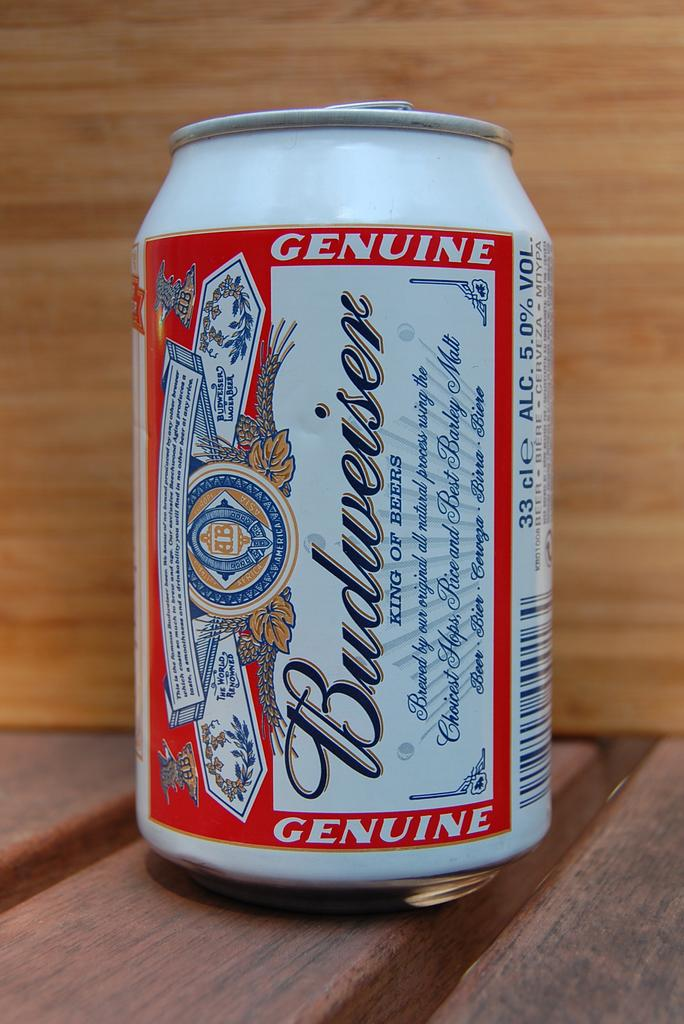<image>
Present a compact description of the photo's key features. the word Budweiser that is on a can 